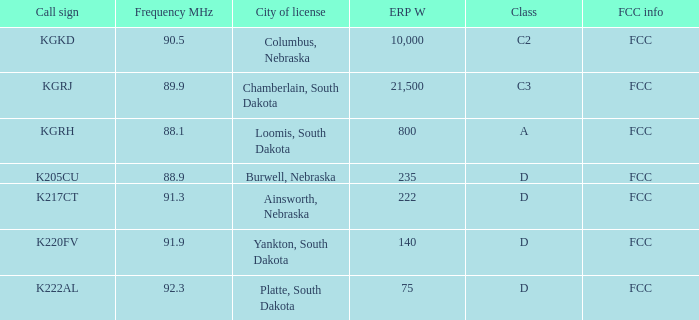What is the cumulative frequency in mhz for the kgrj call sign, with an erp w exceeding 21,500? 0.0. 